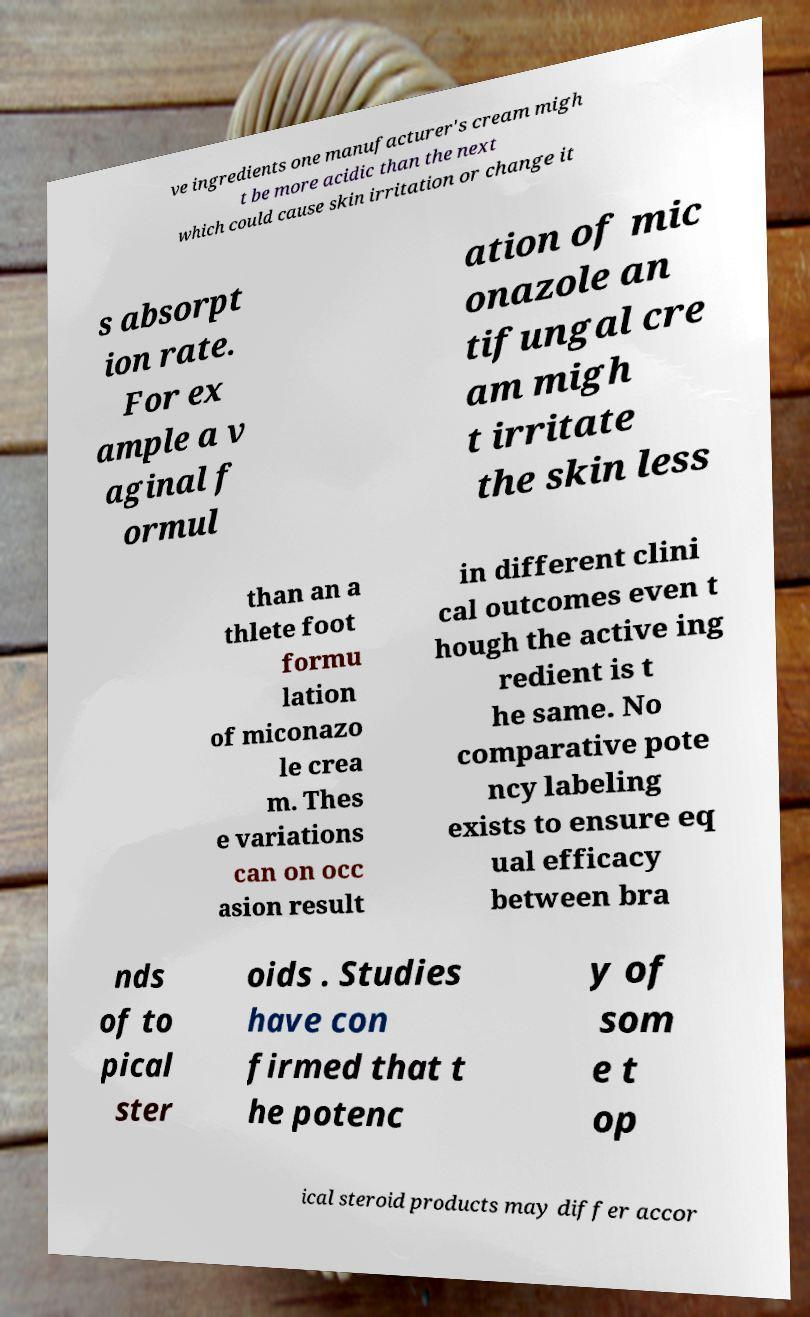There's text embedded in this image that I need extracted. Can you transcribe it verbatim? ve ingredients one manufacturer's cream migh t be more acidic than the next which could cause skin irritation or change it s absorpt ion rate. For ex ample a v aginal f ormul ation of mic onazole an tifungal cre am migh t irritate the skin less than an a thlete foot formu lation of miconazo le crea m. Thes e variations can on occ asion result in different clini cal outcomes even t hough the active ing redient is t he same. No comparative pote ncy labeling exists to ensure eq ual efficacy between bra nds of to pical ster oids . Studies have con firmed that t he potenc y of som e t op ical steroid products may differ accor 